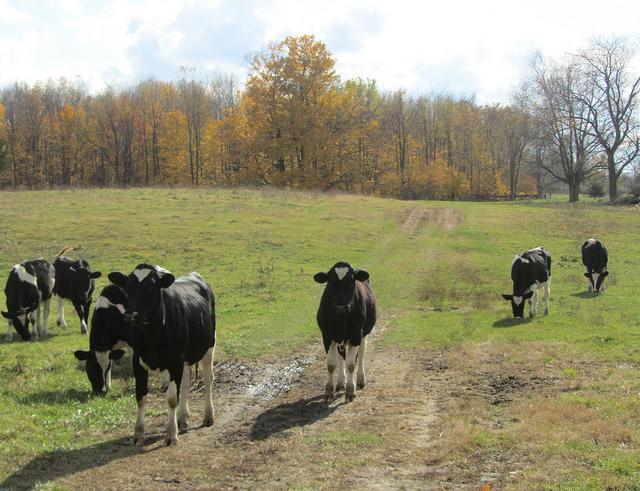How many animals are in the picture?
Give a very brief answer. 7. How many cows are in the picture?
Give a very brief answer. 5. How many people have blonde hair?
Give a very brief answer. 0. 